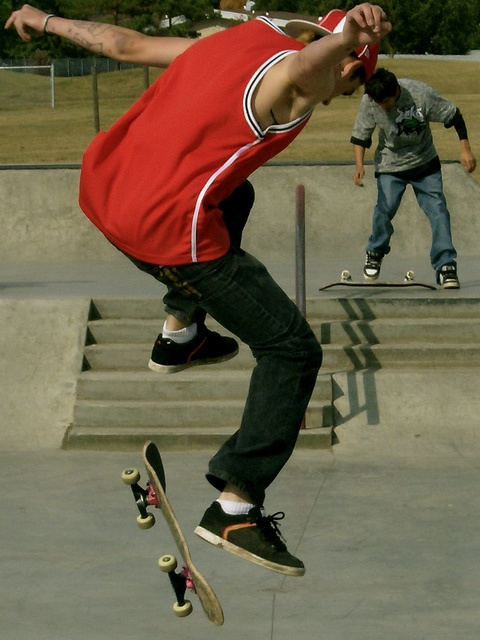Describe the objects in this image and their specific colors. I can see people in darkgreen, black, brown, and maroon tones, people in darkgreen, black, gray, and teal tones, skateboard in darkgreen, black, olive, gray, and tan tones, and skateboard in darkgreen, black, and gray tones in this image. 